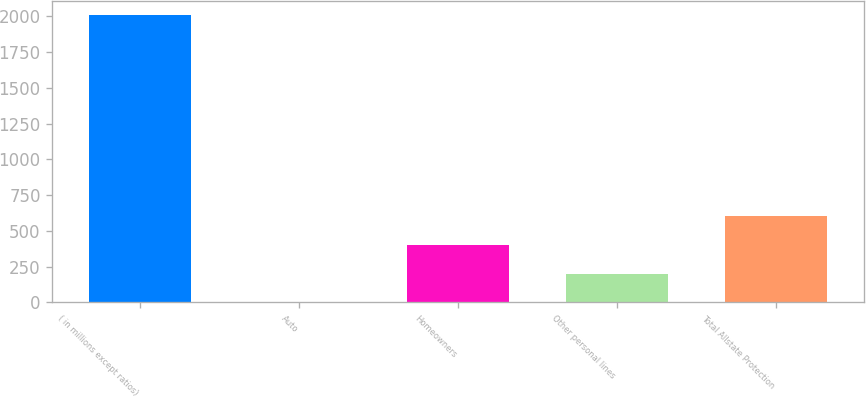Convert chart. <chart><loc_0><loc_0><loc_500><loc_500><bar_chart><fcel>( in millions except ratios)<fcel>Auto<fcel>Homeowners<fcel>Other personal lines<fcel>Total Allstate Protection<nl><fcel>2008<fcel>0.1<fcel>401.68<fcel>200.89<fcel>602.47<nl></chart> 